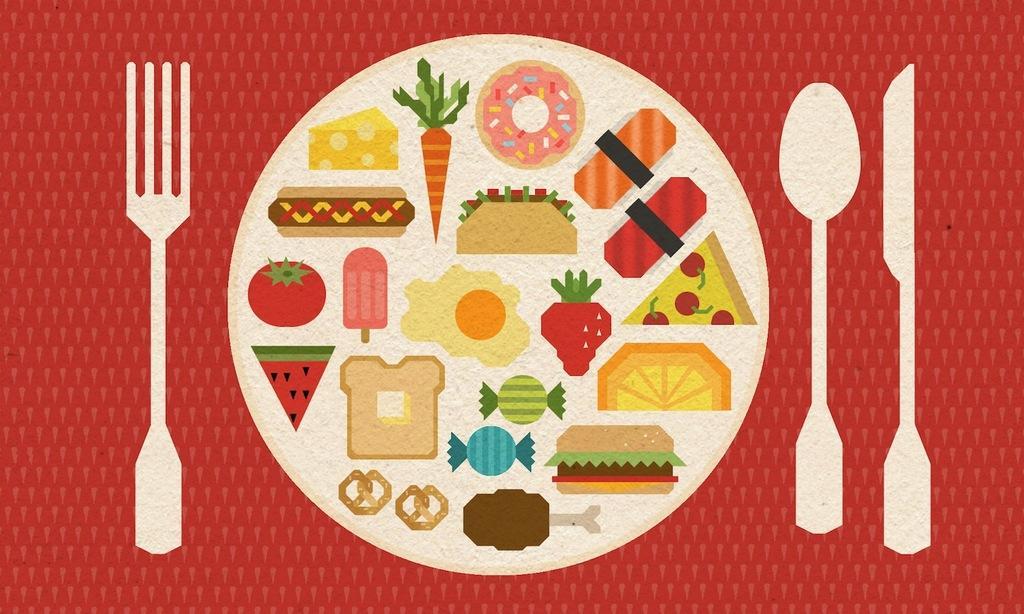How would you summarize this image in a sentence or two? This image consists of a poster with an image of a plate with food items, a fork, a spoon and a knife on it. There are a few toffees, a few fruits, vegetables and many food items on the plate. 